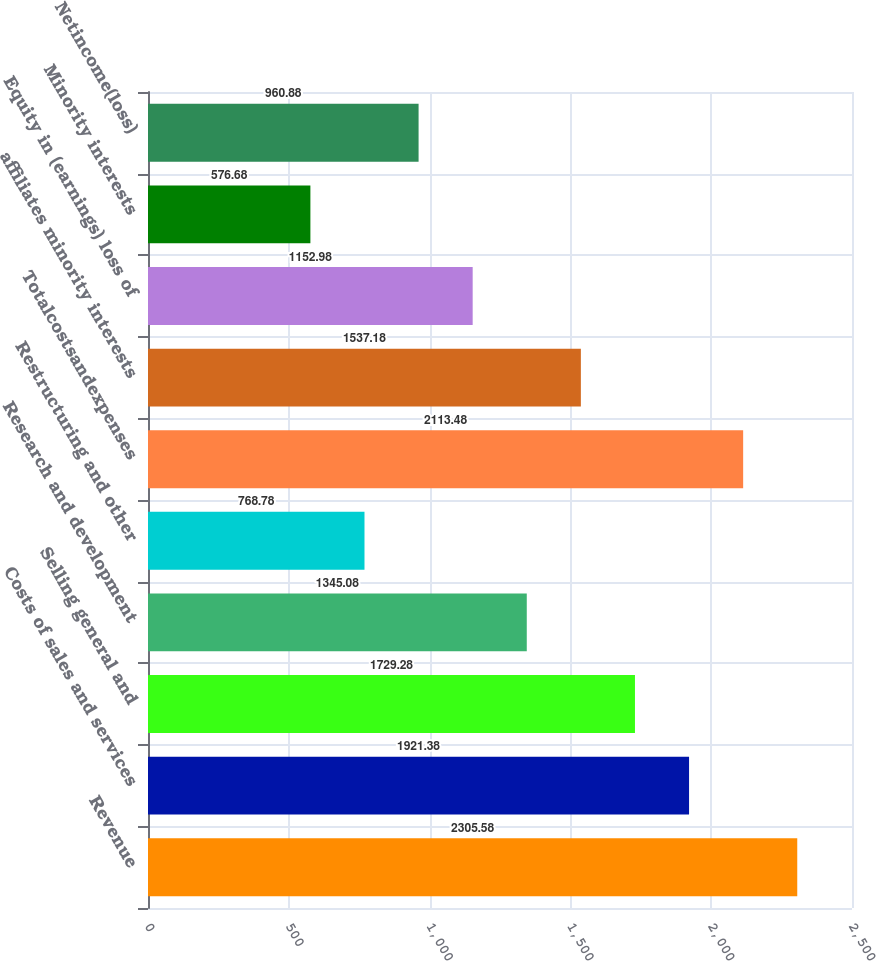<chart> <loc_0><loc_0><loc_500><loc_500><bar_chart><fcel>Revenue<fcel>Costs of sales and services<fcel>Selling general and<fcel>Research and development<fcel>Restructuring and other<fcel>Totalcostsandexpenses<fcel>affiliates minority interests<fcel>Equity in (earnings) loss of<fcel>Minority interests<fcel>Netincome(loss)<nl><fcel>2305.58<fcel>1921.38<fcel>1729.28<fcel>1345.08<fcel>768.78<fcel>2113.48<fcel>1537.18<fcel>1152.98<fcel>576.68<fcel>960.88<nl></chart> 